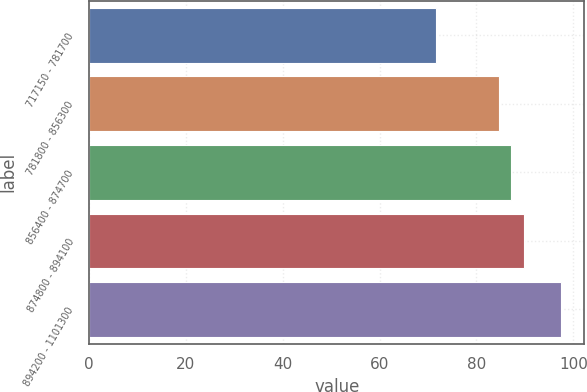<chart> <loc_0><loc_0><loc_500><loc_500><bar_chart><fcel>717150 - 781700<fcel>781800 - 856300<fcel>856400 - 874700<fcel>874800 - 894100<fcel>894200 - 1101300<nl><fcel>71.72<fcel>84.63<fcel>87.2<fcel>89.77<fcel>97.41<nl></chart> 